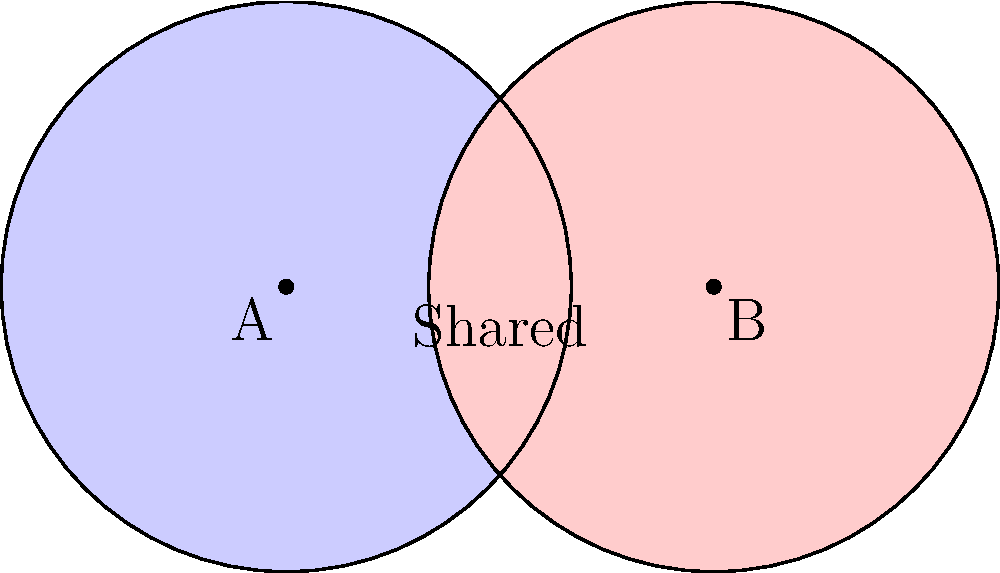In a relationship counseling session, you use a Venn diagram to represent shared interests between two partners. Each circle has a radius of 5 units, and their centers are 7.5 units apart. What is the area of the overlapping region (shared interests) rounded to two decimal places? To find the area of the overlapping region, we'll follow these steps:

1) First, we need to find the central angle $\theta$ of the sector formed in each circle:

   $\cos(\frac{\theta}{2}) = \frac{d/2}{r} = \frac{7.5/2}{5} = 0.75$
   
   $\theta = 2 \arccos(0.75) = 1.5708$ radians

2) The area of the sector in each circle is:

   $A_{sector} = \frac{1}{2}r^2\theta = \frac{1}{2}(5^2)(1.5708) = 19.635$ square units

3) The area of the triangle formed by the centers and the intersection points is:

   $A_{triangle} = \frac{1}{2}(7.5)(5\sin(\frac{\theta}{2})) = 11.25$ square units

4) The area of the lens-shaped overlap is twice the difference between the sector and triangle:

   $A_{overlap} = 2(A_{sector} - A_{triangle}) = 2(19.635 - 11.25) = 16.77$ square units

5) Rounding to two decimal places:

   $A_{overlap} \approx 16.77$ square units

This overlapping area represents the shared interests between the partners.
Answer: 16.77 square units 